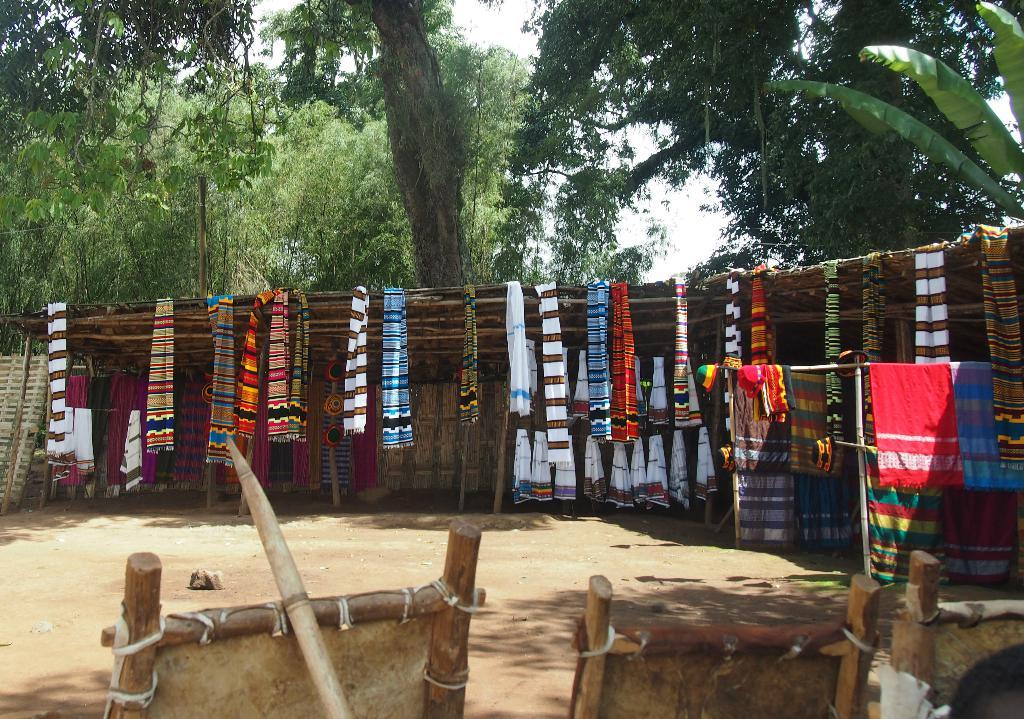What type of objects can be seen at the bottom of the image? There are wooden things at the bottom of the image. What activity is being performed with the clothes in the middle of the image? Clothes are hanged for drying in the middle of the image. What natural elements are visible in the background of the image? There are trees visible at the back side of the image. What type of government is depicted in the image? There is no depiction of a government in the image; it features wooden objects, hanging clothes, and trees. Can you see any underwear hanging among the clothes in the image? The image does not show any specific clothing items, so it is impossible to determine if underwear is among the clothes being dried. 